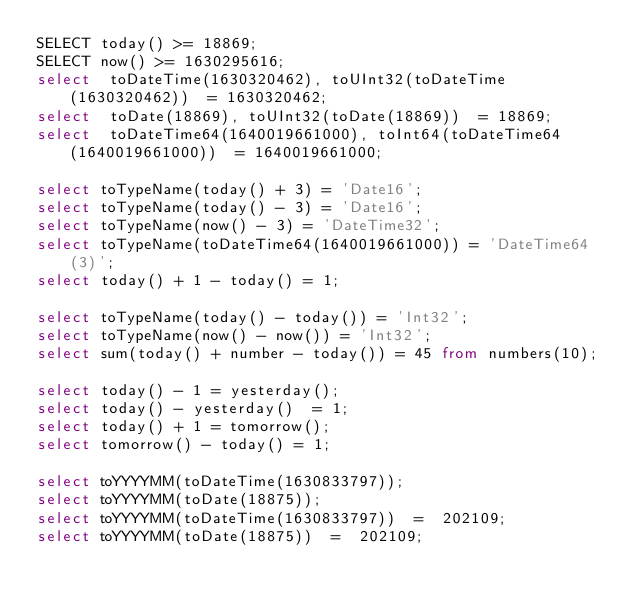<code> <loc_0><loc_0><loc_500><loc_500><_SQL_>SELECT today() >= 18869;
SELECT now() >= 1630295616;
select  toDateTime(1630320462), toUInt32(toDateTime(1630320462))  = 1630320462;
select  toDate(18869), toUInt32(toDate(18869))  = 18869;
select  toDateTime64(1640019661000), toInt64(toDateTime64(1640019661000))  = 1640019661000;

select toTypeName(today() + 3) = 'Date16';
select toTypeName(today() - 3) = 'Date16';
select toTypeName(now() - 3) = 'DateTime32';
select toTypeName(toDateTime64(1640019661000)) = 'DateTime64(3)';
select today() + 1 - today() = 1;

select toTypeName(today() - today()) = 'Int32';
select toTypeName(now() - now()) = 'Int32';
select sum(today() + number - today()) = 45 from numbers(10);

select today() - 1 = yesterday();
select today() - yesterday()  = 1;
select today() + 1 = tomorrow();
select tomorrow() - today() = 1;

select toYYYYMM(toDateTime(1630833797));
select toYYYYMM(toDate(18875));
select toYYYYMM(toDateTime(1630833797))  =  202109;
select toYYYYMM(toDate(18875))  =  202109;
</code> 